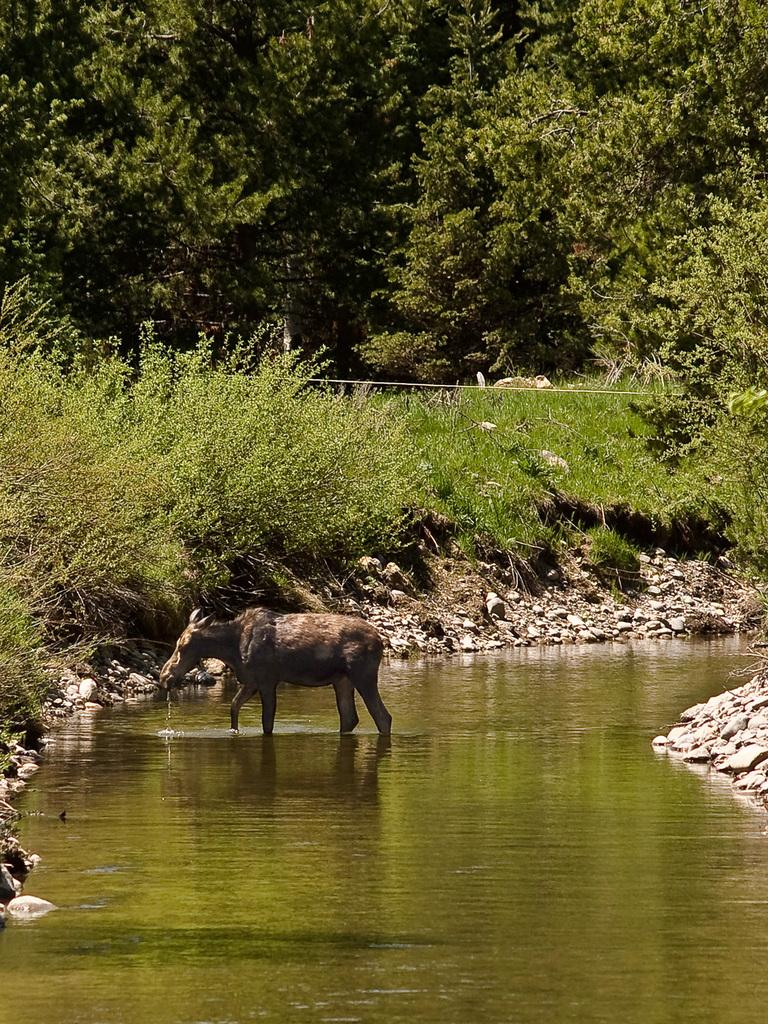What is the animal doing in the image? The animal is standing in the water. What type of vegetation can be seen in the image? There are many plants and trees in the image. What insect is responsible for the selection of friends in the image? There is no insect or mention of selecting friends in the image. 